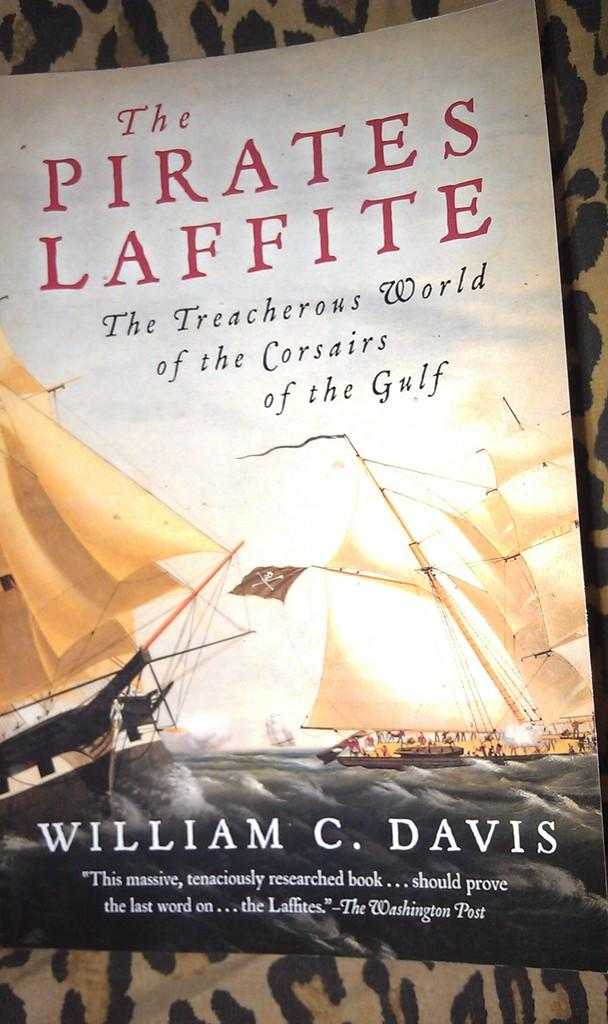<image>
Describe the image concisely. Book titled The Pirates Laffite showing a ship on the cover. 